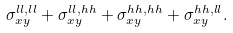<formula> <loc_0><loc_0><loc_500><loc_500>\sigma _ { x y } ^ { l l , l l } + \sigma _ { x y } ^ { l l , h h } + \sigma _ { x y } ^ { h h , h h } + \sigma _ { x y } ^ { h h , l l } .</formula> 